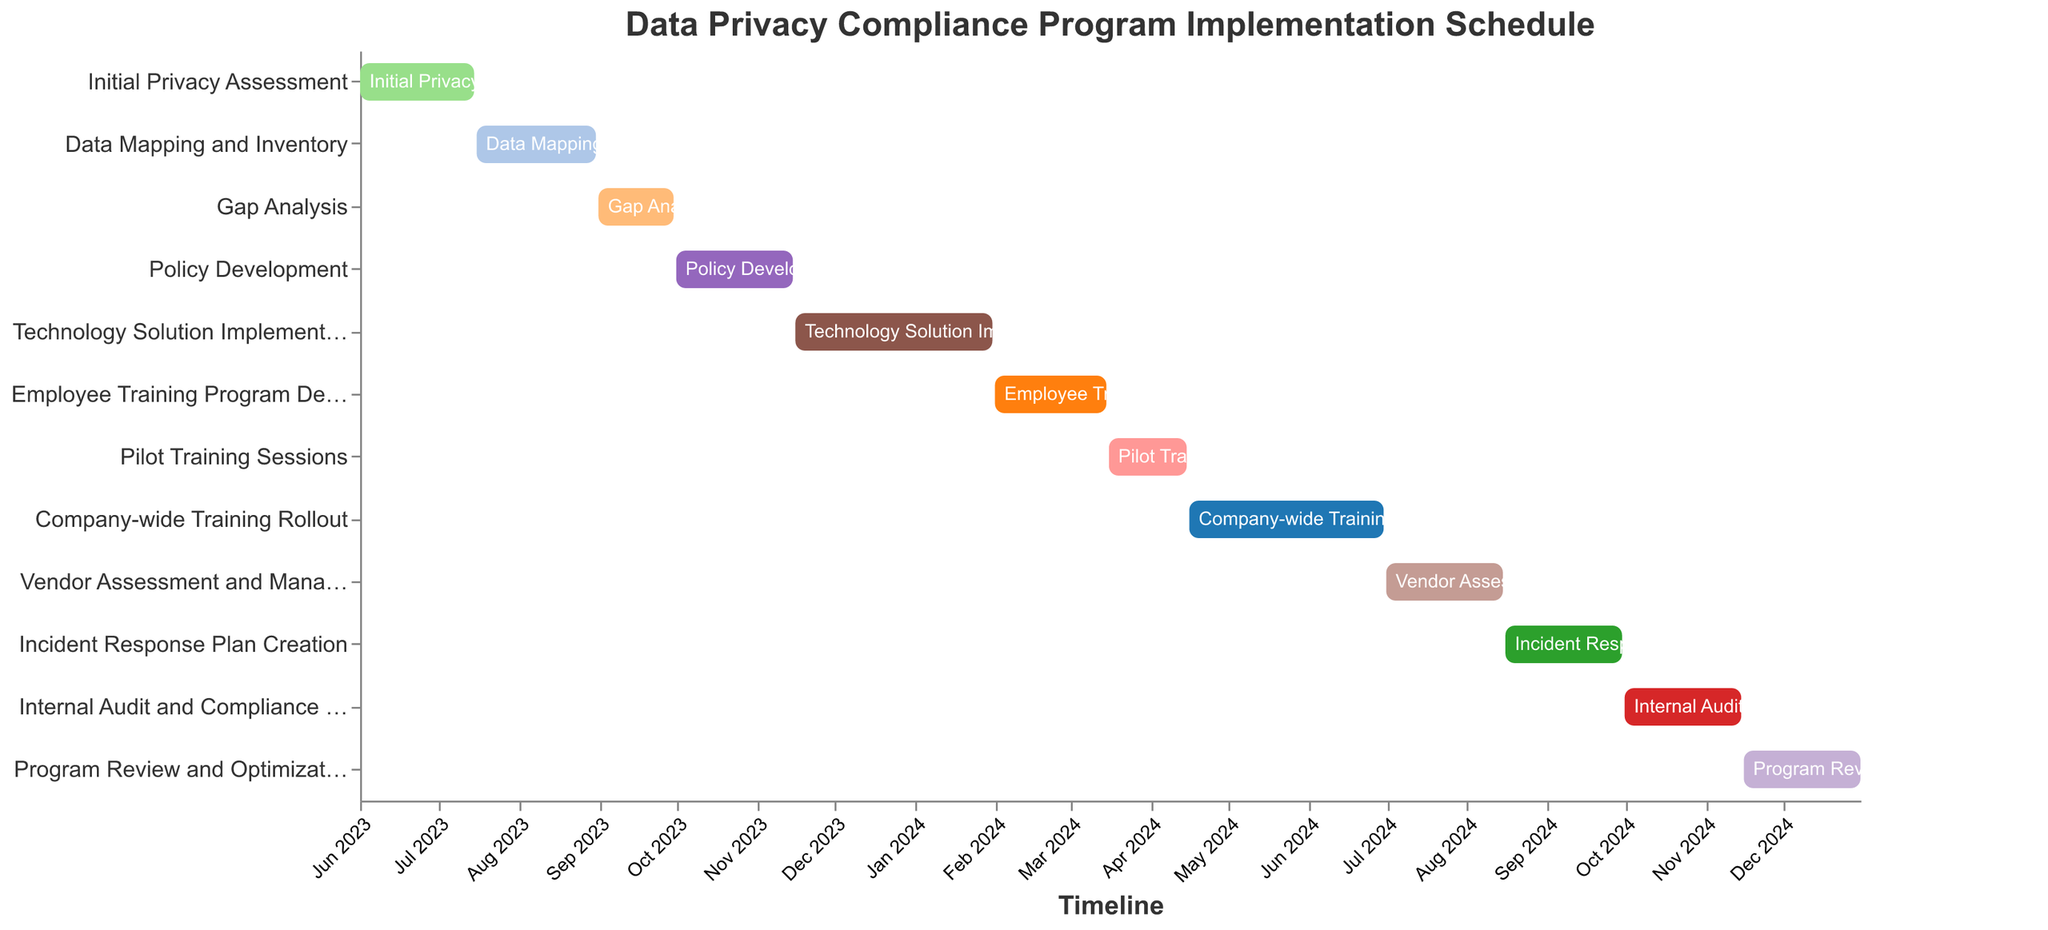What is the duration of the "Technology Solution Implementation" phase? Look at the bar representing the "Technology Solution Implementation" task and refer to the data table where the duration is listed.
Answer: 77 days When does the "Policy Development" phase start and end? Identify the "Policy Development" task on the chart. The "Start Date" is 2023-10-01 and the "End Date" is 2023-11-15.
Answer: Starts on 2023-10-01 and ends on 2023-11-15 Which task directly follows the "Gap Analysis" phase? Observe the end date of the "Gap Analysis" and check the next starting date. "Policy Development" starts right after "Gap Analysis".
Answer: Policy Development How much time is there between the end of "Data Mapping and Inventory" and the start of "Gap Analysis"? "Data Mapping and Inventory" ends on 2023-08-31 and "Gap Analysis" begins on 2023-09-01. The tasks are consecutive, so there is no gap.
Answer: 0 days Which phase has the longest duration? Compare the durations of all tasks and identify the one with the maximum value. The "Technology Solution Implementation" phase lasts the longest.
Answer: Technology Solution Implementation Compare the duration of "Employee Training Program Development" with "Pilot Training Sessions". Which one is longer? Look at the durations of both tasks in the data. "Employee Training Program Development" is 44 days and "Pilot Training Sessions" is 31 days.
Answer: Employee Training Program Development What is the total duration for both "Incident Response Plan Creation" and "Internal Audit and Compliance Check"? Sum the durations of "Incident Response Plan Creation" (46 days) and "Internal Audit and Compliance Check" (46 days). 46 + 46 = 92 days.
Answer: 92 days Identify a task that overlaps with "Company-wide Training Rollout". When does this overlap begin? Referring to the Gantt chart, "Vendor Assessment and Management" overlaps with "Company-wide Training Rollout". The overlap begins on 2024-07-01.
Answer: 2024-07-01 When does the entire data privacy compliance program begin and end? The program begins with "Initial Privacy Assessment" starting on 2023-06-01 and ends with "Program Review and Optimization" on 2024-12-31.
Answer: Starts on 2023-06-01 and ends on 2024-12-31 